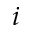Convert formula to latex. <formula><loc_0><loc_0><loc_500><loc_500>i</formula> 